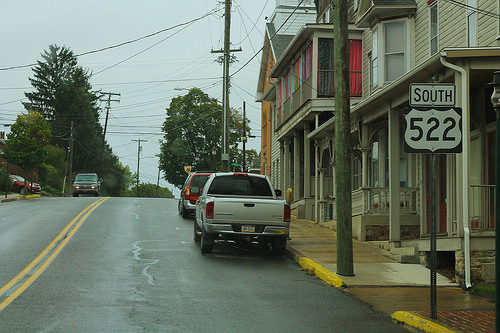<image>
Is there a car on the road? Yes. Looking at the image, I can see the car is positioned on top of the road, with the road providing support. 